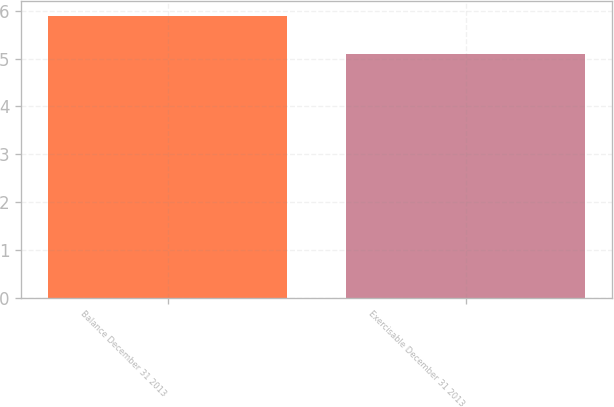<chart> <loc_0><loc_0><loc_500><loc_500><bar_chart><fcel>Balance December 31 2013<fcel>Exercisable December 31 2013<nl><fcel>5.9<fcel>5.1<nl></chart> 